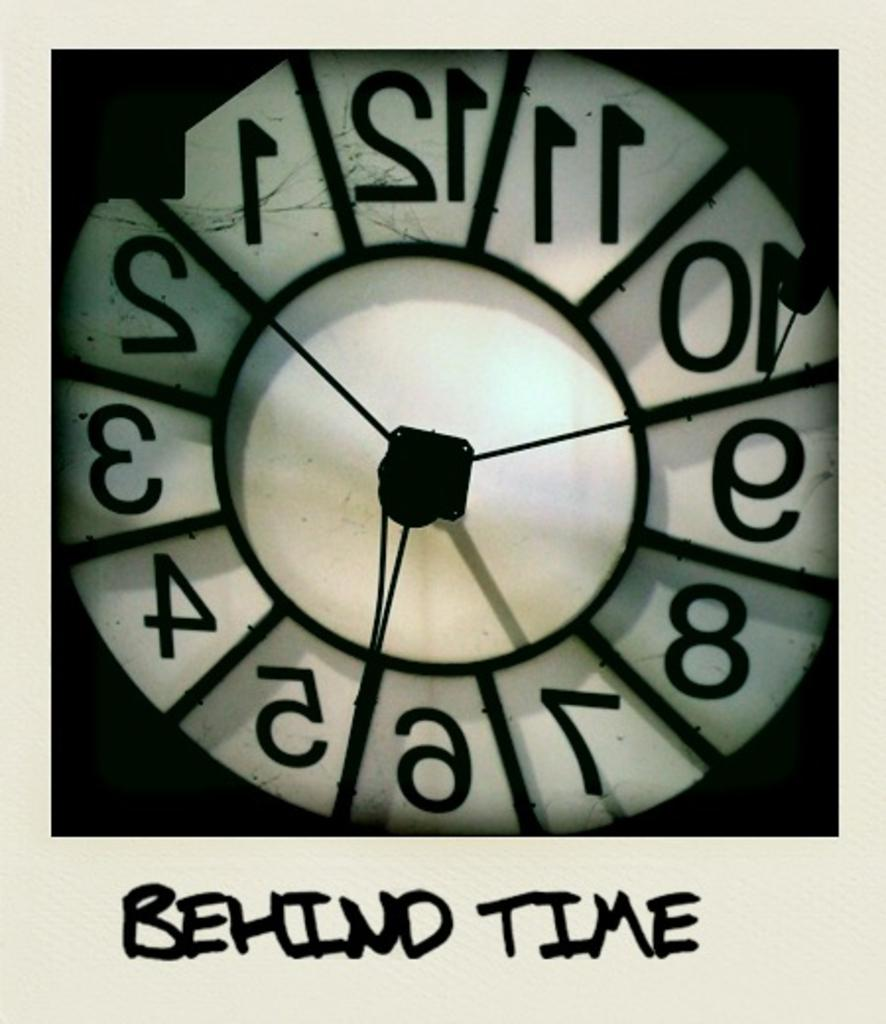<image>
Present a compact description of the photo's key features. A backwards clock has the words BEHIND TIME written beneath it 